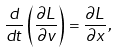<formula> <loc_0><loc_0><loc_500><loc_500>\frac { d } { d t } \left ( \frac { \partial L } { \partial v } \right ) = \frac { \partial L } { \partial x } ,</formula> 